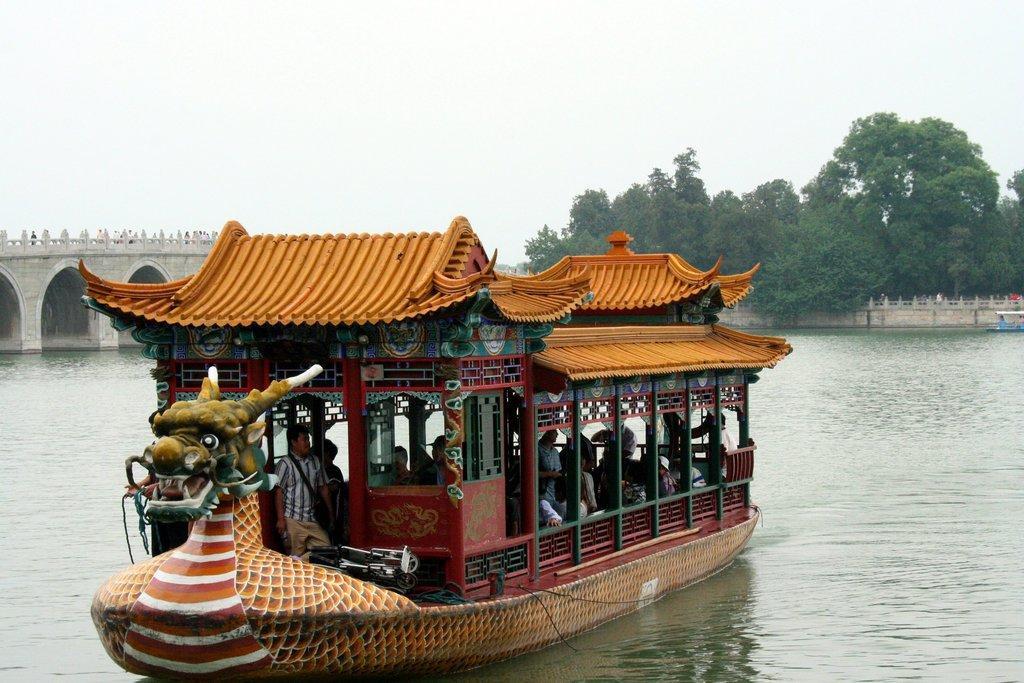Can you describe this image briefly? In this image we can see many people sailing in the watercraft. There is a watercraft at the right side of the image. We can see the lake in the image. We can see the sky in the image. There are many trees in the image. We can see few people on the bridge at the left side of the image. 